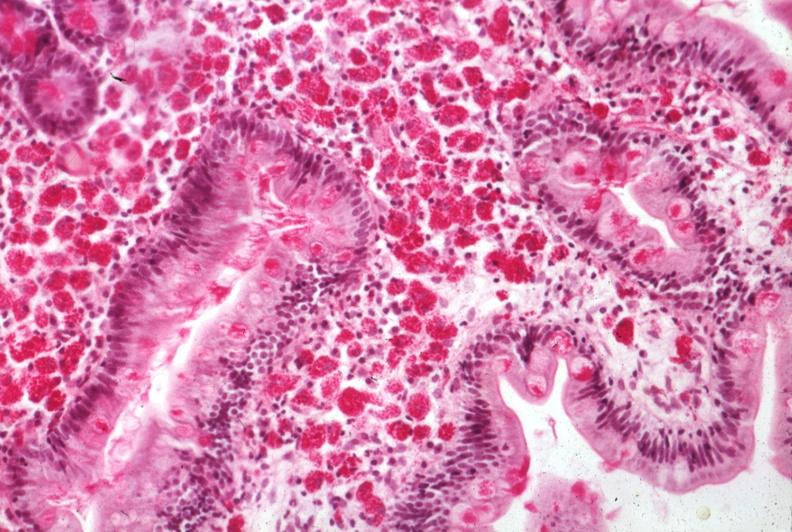s gastrointestinal present?
Answer the question using a single word or phrase. Yes 